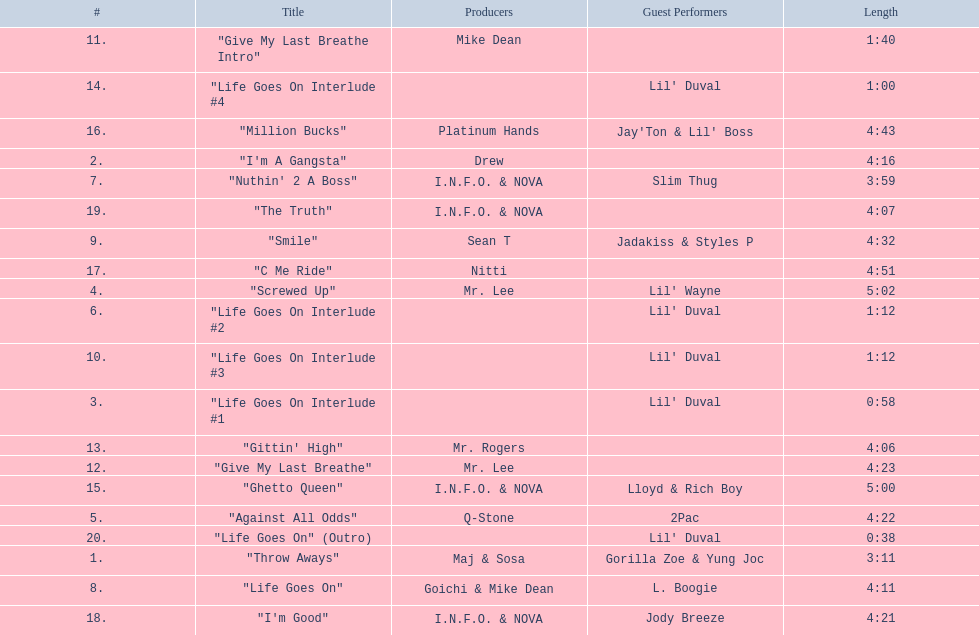Which tracks are longer than 4.00? "I'm A Gangsta", "Screwed Up", "Against All Odds", "Life Goes On", "Smile", "Give My Last Breathe", "Gittin' High", "Ghetto Queen", "Million Bucks", "C Me Ride", "I'm Good", "The Truth". Of those, which tracks are longer than 4.30? "Screwed Up", "Smile", "Ghetto Queen", "Million Bucks", "C Me Ride". Of those, which tracks are 5.00 or longer? "Screwed Up", "Ghetto Queen". Of those, which one is the longest? "Screwed Up". How long is that track? 5:02. 